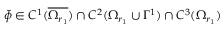<formula> <loc_0><loc_0><loc_500><loc_500>\bar { \phi } \in C ^ { 1 } ( \overline { { \Omega _ { r _ { 1 } } } } ) \cap C ^ { 2 } ( \Omega _ { r _ { 1 } } \cup \Gamma ^ { 1 } ) \cap C ^ { 3 } ( \Omega _ { r _ { 1 } } )</formula> 